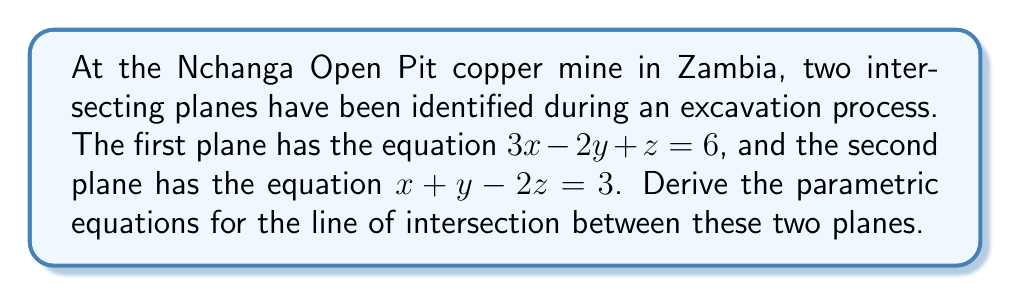Could you help me with this problem? To find the parametric equations of the line of intersection, we'll follow these steps:

1) First, we need to find the direction vector of the line. This is given by the cross product of the normal vectors of the two planes.

   Plane 1: $3x - 2y + z = 6$, normal vector $\mathbf{n_1} = (3, -2, 1)$
   Plane 2: $x + y - 2z = 3$, normal vector $\mathbf{n_2} = (1, 1, -2)$

   Direction vector $\mathbf{d} = \mathbf{n_1} \times \mathbf{n_2}$:
   
   $$\mathbf{d} = \begin{vmatrix} 
   \mathbf{i} & \mathbf{j} & \mathbf{k} \\
   3 & -2 & 1 \\
   1 & 1 & -2
   \end{vmatrix} = (3, 5, 5)$$

2) Next, we need to find a point on the line. We can do this by solving the system of equations:

   $$\begin{cases}
   3x - 2y + z = 6 \\
   x + y - 2z = 3
   \end{cases}$$

   Let's set $z = 0$ for simplicity. Then:

   $$\begin{cases}
   3x - 2y = 6 \\
   x + y = 3
   \end{cases}$$

   Solving this system gives us $x = 2$ and $y = 1$ when $z = 0$.

3) Now we have a point on the line $(2, 1, 0)$ and a direction vector $(3, 5, 5)$.

4) The parametric equations of the line are:

   $$\begin{cases}
   x = 2 + 3t \\
   y = 1 + 5t \\
   z = 5t
   \end{cases}$$

   where $t$ is a parameter that can take any real value.
Answer: $x = 2 + 3t$, $y = 1 + 5t$, $z = 5t$ 